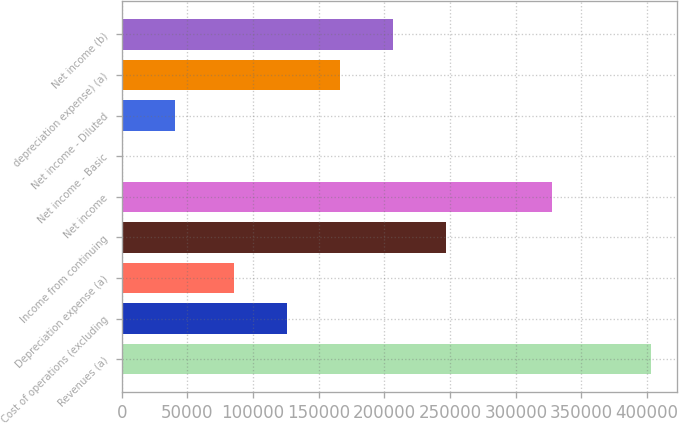Convert chart to OTSL. <chart><loc_0><loc_0><loc_500><loc_500><bar_chart><fcel>Revenues (a)<fcel>Cost of operations (excluding<fcel>Depreciation expense (a)<fcel>Income from continuing<fcel>Net income<fcel>Net income - Basic<fcel>Net income - Diluted<fcel>depreciation expense) (a)<fcel>Net income (b)<nl><fcel>402879<fcel>125851<fcel>85563<fcel>246714<fcel>327290<fcel>0.7<fcel>40288.5<fcel>166139<fcel>206426<nl></chart> 